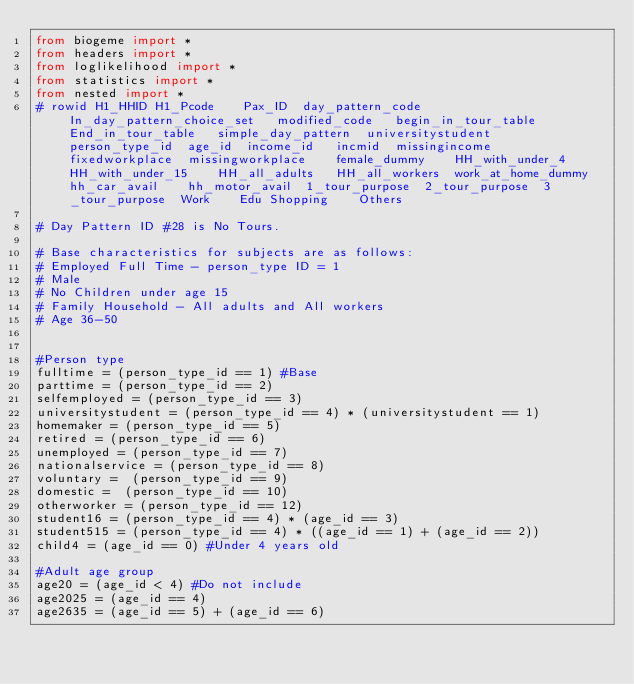<code> <loc_0><loc_0><loc_500><loc_500><_Python_>from biogeme import *
from headers import *
from loglikelihood import *
from statistics import *
from nested import *
# rowid	H1_HHID	H1_Pcode	Pax_ID	day_pattern_code	In_day_pattern_choice_set	modified_code	begin_in_tour_table	End_in_tour_table	simple_day_pattern	universitystudent	person_type_id	age_id	income_id	incmid	missingincome	fixedworkplace	missingworkplace	female_dummy	HH_with_under_4	HH_with_under_15	HH_all_adults	HH_all_workers	work_at_home_dummy	hh_car_avail	hh_motor_avail	1_tour_purpose	2_tour_purpose	3_tour_purpose	Work	Edu	Shopping	Others		

# Day Pattern ID #28 is No Tours.

# Base characteristics for subjects are as follows:
# Employed Full Time - person_type ID = 1
# Male
# No Children under age 15
# Family Household - All adults and All workers
# Age 36-50


#Person type
fulltime = (person_type_id == 1) #Base
parttime = (person_type_id == 2)
selfemployed = (person_type_id == 3)
universitystudent = (person_type_id == 4) * (universitystudent == 1)
homemaker = (person_type_id == 5)
retired = (person_type_id == 6)
unemployed = (person_type_id == 7)
nationalservice = (person_type_id == 8)
voluntary =  (person_type_id == 9)
domestic =  (person_type_id == 10)
otherworker = (person_type_id == 12)
student16 = (person_type_id == 4) * (age_id == 3)
student515 = (person_type_id == 4) * ((age_id == 1) + (age_id == 2))
child4 = (age_id == 0) #Under 4 years old

#Adult age group
age20 = (age_id < 4) #Do not include
age2025 = (age_id == 4)
age2635 = (age_id == 5) + (age_id == 6)</code> 